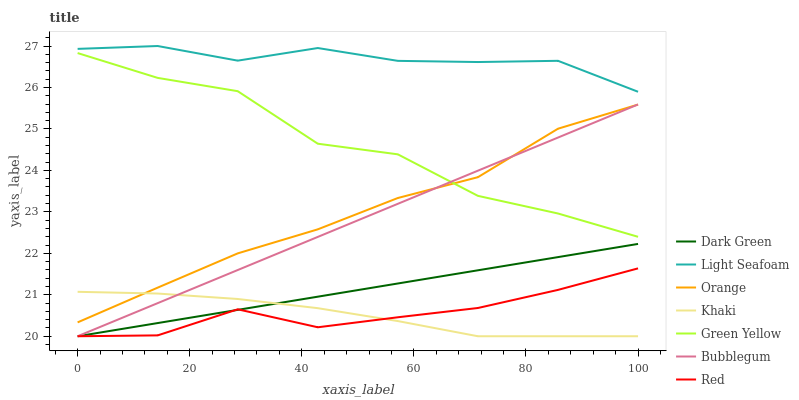Does Khaki have the minimum area under the curve?
Answer yes or no. Yes. Does Light Seafoam have the maximum area under the curve?
Answer yes or no. Yes. Does Bubblegum have the minimum area under the curve?
Answer yes or no. No. Does Bubblegum have the maximum area under the curve?
Answer yes or no. No. Is Dark Green the smoothest?
Answer yes or no. Yes. Is Green Yellow the roughest?
Answer yes or no. Yes. Is Bubblegum the smoothest?
Answer yes or no. No. Is Bubblegum the roughest?
Answer yes or no. No. Does Bubblegum have the lowest value?
Answer yes or no. Yes. Does Orange have the lowest value?
Answer yes or no. No. Does Light Seafoam have the highest value?
Answer yes or no. Yes. Does Bubblegum have the highest value?
Answer yes or no. No. Is Dark Green less than Orange?
Answer yes or no. Yes. Is Light Seafoam greater than Red?
Answer yes or no. Yes. Does Khaki intersect Red?
Answer yes or no. Yes. Is Khaki less than Red?
Answer yes or no. No. Is Khaki greater than Red?
Answer yes or no. No. Does Dark Green intersect Orange?
Answer yes or no. No. 